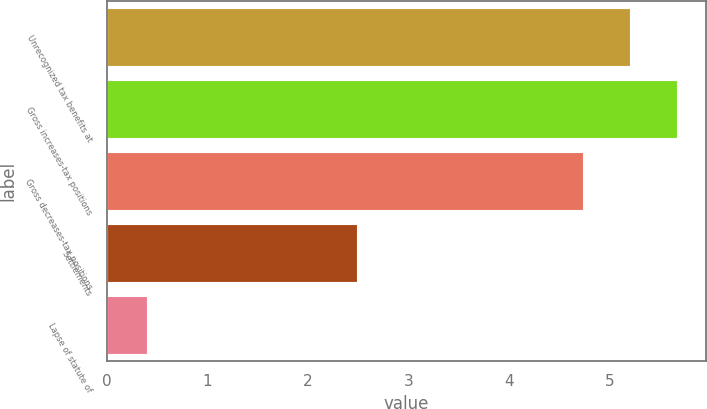Convert chart. <chart><loc_0><loc_0><loc_500><loc_500><bar_chart><fcel>Unrecognized tax benefits at<fcel>Gross increases-tax positions<fcel>Gross decreases-tax positions<fcel>Settlements<fcel>Lapse of statute of<nl><fcel>5.2<fcel>5.67<fcel>4.73<fcel>2.49<fcel>0.4<nl></chart> 